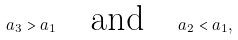<formula> <loc_0><loc_0><loc_500><loc_500>a _ { 3 } > a _ { 1 } \quad \text {and} \quad a _ { 2 } < a _ { 1 } ,</formula> 